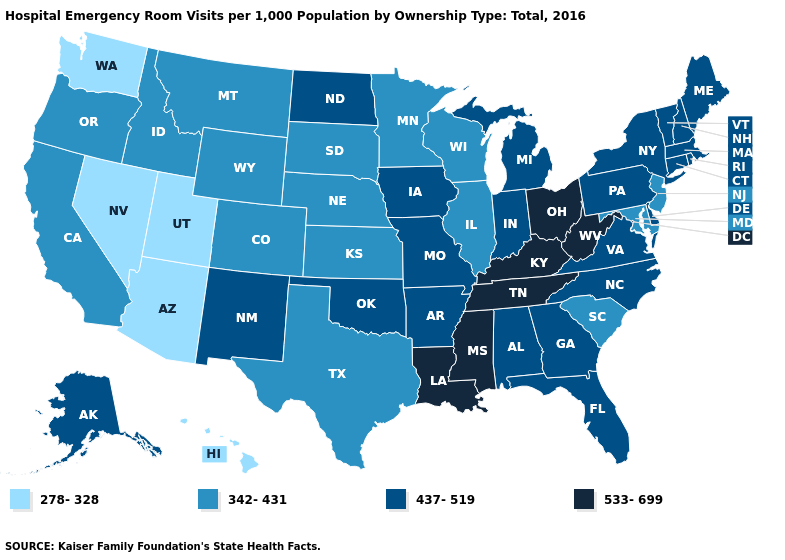Does Minnesota have the same value as Hawaii?
Give a very brief answer. No. What is the value of Missouri?
Concise answer only. 437-519. Is the legend a continuous bar?
Give a very brief answer. No. Name the states that have a value in the range 533-699?
Give a very brief answer. Kentucky, Louisiana, Mississippi, Ohio, Tennessee, West Virginia. Does Tennessee have a lower value than Nevada?
Short answer required. No. Does New Hampshire have the lowest value in the Northeast?
Quick response, please. No. Does Alabama have the highest value in the USA?
Quick response, please. No. Does Pennsylvania have the same value as South Carolina?
Concise answer only. No. What is the value of Washington?
Keep it brief. 278-328. Which states hav the highest value in the Northeast?
Keep it brief. Connecticut, Maine, Massachusetts, New Hampshire, New York, Pennsylvania, Rhode Island, Vermont. Does North Dakota have the highest value in the MidWest?
Be succinct. No. Among the states that border Oregon , does Idaho have the highest value?
Concise answer only. Yes. What is the value of Texas?
Be succinct. 342-431. What is the value of Ohio?
Quick response, please. 533-699. Name the states that have a value in the range 278-328?
Quick response, please. Arizona, Hawaii, Nevada, Utah, Washington. 